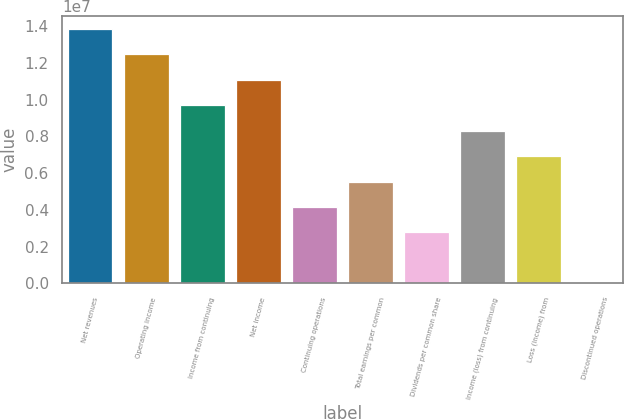<chart> <loc_0><loc_0><loc_500><loc_500><bar_chart><fcel>Net revenues<fcel>Operating income<fcel>Income from continuing<fcel>Net income<fcel>Continuing operations<fcel>Total earnings per common<fcel>Dividends per common share<fcel>Income (loss) from continuing<fcel>Loss (income) from<fcel>Discontinued operations<nl><fcel>1.38487e+07<fcel>1.24638e+07<fcel>9.69406e+06<fcel>1.10789e+07<fcel>4.1546e+06<fcel>5.53946e+06<fcel>2.76973e+06<fcel>8.3092e+06<fcel>6.92433e+06<fcel>0.27<nl></chart> 